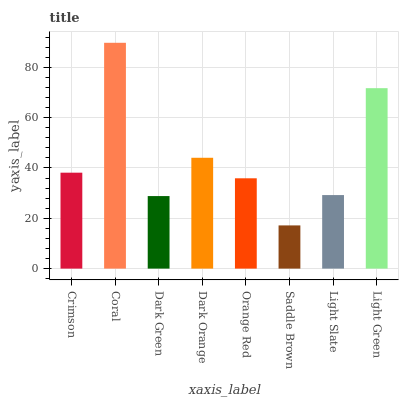Is Saddle Brown the minimum?
Answer yes or no. Yes. Is Coral the maximum?
Answer yes or no. Yes. Is Dark Green the minimum?
Answer yes or no. No. Is Dark Green the maximum?
Answer yes or no. No. Is Coral greater than Dark Green?
Answer yes or no. Yes. Is Dark Green less than Coral?
Answer yes or no. Yes. Is Dark Green greater than Coral?
Answer yes or no. No. Is Coral less than Dark Green?
Answer yes or no. No. Is Crimson the high median?
Answer yes or no. Yes. Is Orange Red the low median?
Answer yes or no. Yes. Is Light Green the high median?
Answer yes or no. No. Is Crimson the low median?
Answer yes or no. No. 